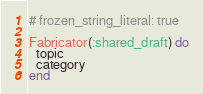<code> <loc_0><loc_0><loc_500><loc_500><_Ruby_># frozen_string_literal: true

Fabricator(:shared_draft) do
  topic
  category
end
</code> 